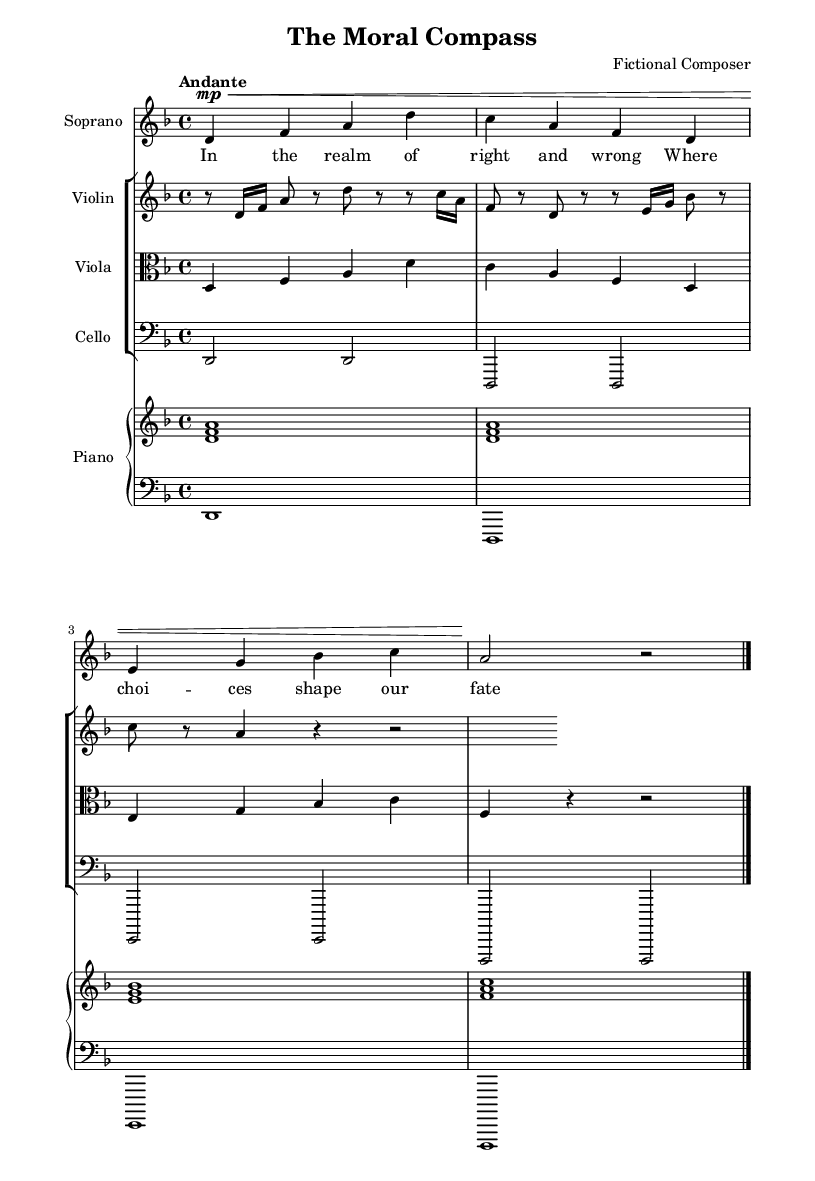What is the key signature of this music? The key signature is D minor, which contains one flat (B flat). This can be determined by looking at the key signature indicated at the beginning of the sheet music, where there is a flat symbol on the B line.
Answer: D minor What is the time signature of this music? The time signature is 4/4, which is indicated at the beginning of the score. It shows that there are four beats per measure and the quarter note receives one beat.
Answer: 4/4 What is the tempo marking in this score? The tempo marking is "Andante," which is a term used in music to indicate a moderate walking pace. It is placed above the staff at the beginning of the score to guide the performer on the speed of the piece.
Answer: Andante How many vocal parts are present in the score? There is one vocal part indicated in the score, specifically for soprano. The soprano part contains musical notation and lyrics, clearly delineating it from the instrumental sections.
Answer: One What instruments are included in the ensemble? The instruments listed in the ensemble are Violin, Viola, Cello, and Piano. Each instrument has its own staff, as indicated in the score, showing the arrangement of the musicians in the piece.
Answer: Violin, Viola, Cello, Piano What are the lyrics for the Soprano voice? The lyrics for the Soprano voice reflect themes of morality, reading: "In the realm of right and wrong / Where choices shape our fate / The path of virtue calls us / Before." This can be found written below the musical staff designated for the soprano.
Answer: "In the realm of right and wrong / Where choices shape our fate / The path of virtue calls us / Before." 